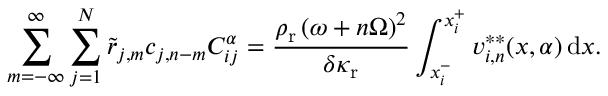Convert formula to latex. <formula><loc_0><loc_0><loc_500><loc_500>\sum _ { m = - \infty } ^ { \infty } \sum _ { j = 1 } ^ { N } \tilde { r } _ { j , m } c _ { j , n - m } C _ { i j } ^ { \alpha } = \frac { \rho _ { r } \left ( \omega + n \Omega \right ) ^ { 2 } } { \delta \kappa _ { r } } \int _ { x _ { i } ^ { - } } ^ { x _ { i } ^ { + } } v _ { i , n } ^ { * * } ( x , \alpha ) \, d x .</formula> 